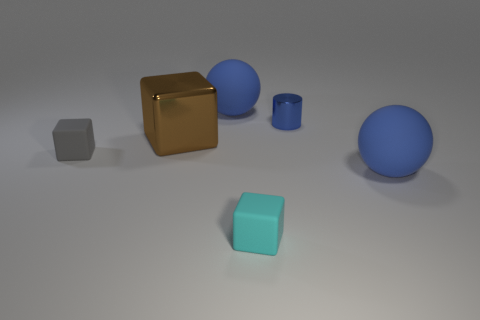How many other objects are there of the same material as the small blue cylinder?
Offer a very short reply. 1. There is a thing in front of the large thing in front of the brown shiny thing; what is its shape?
Provide a succinct answer. Cube. How many things are purple cubes or large blue matte balls behind the tiny cyan rubber thing?
Provide a short and direct response. 2. What number of other things are there of the same color as the tiny shiny cylinder?
Your response must be concise. 2. What number of blue things are either big cubes or big things?
Offer a very short reply. 2. Are there any small gray matte objects that are in front of the big rubber thing right of the sphere that is behind the brown thing?
Your answer should be compact. No. Is there any other thing that is the same size as the metallic block?
Give a very brief answer. Yes. Is the small cylinder the same color as the metal block?
Give a very brief answer. No. The thing in front of the big blue matte ball in front of the small blue metal cylinder is what color?
Make the answer very short. Cyan. How many small objects are blue metal things or blue balls?
Your response must be concise. 1. 